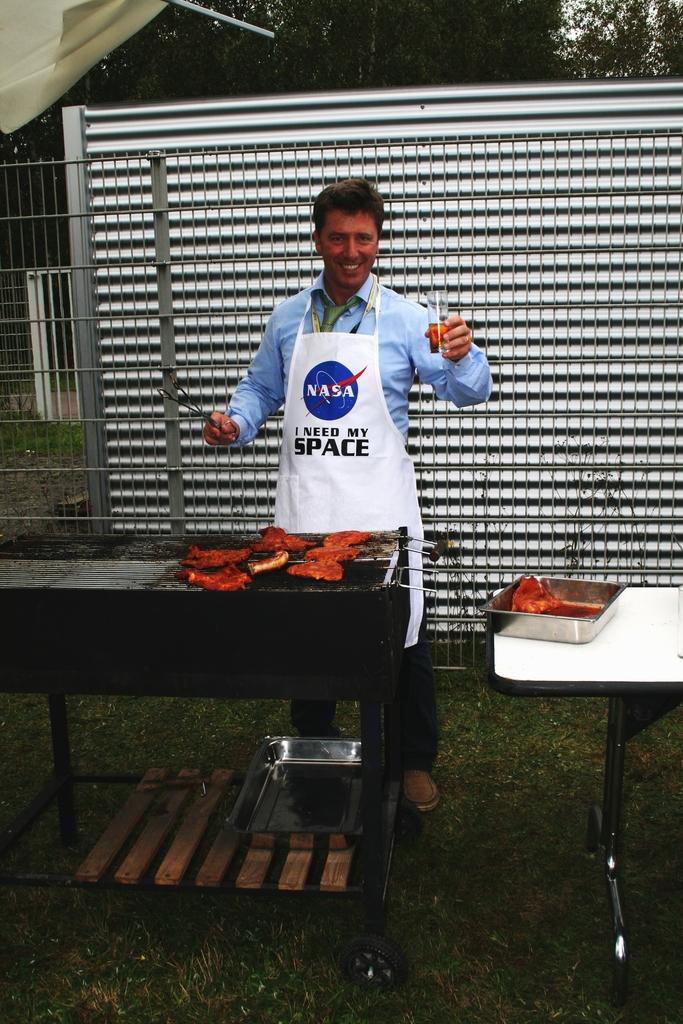What is written on the apron?
Offer a terse response. Nasa i need my space. 